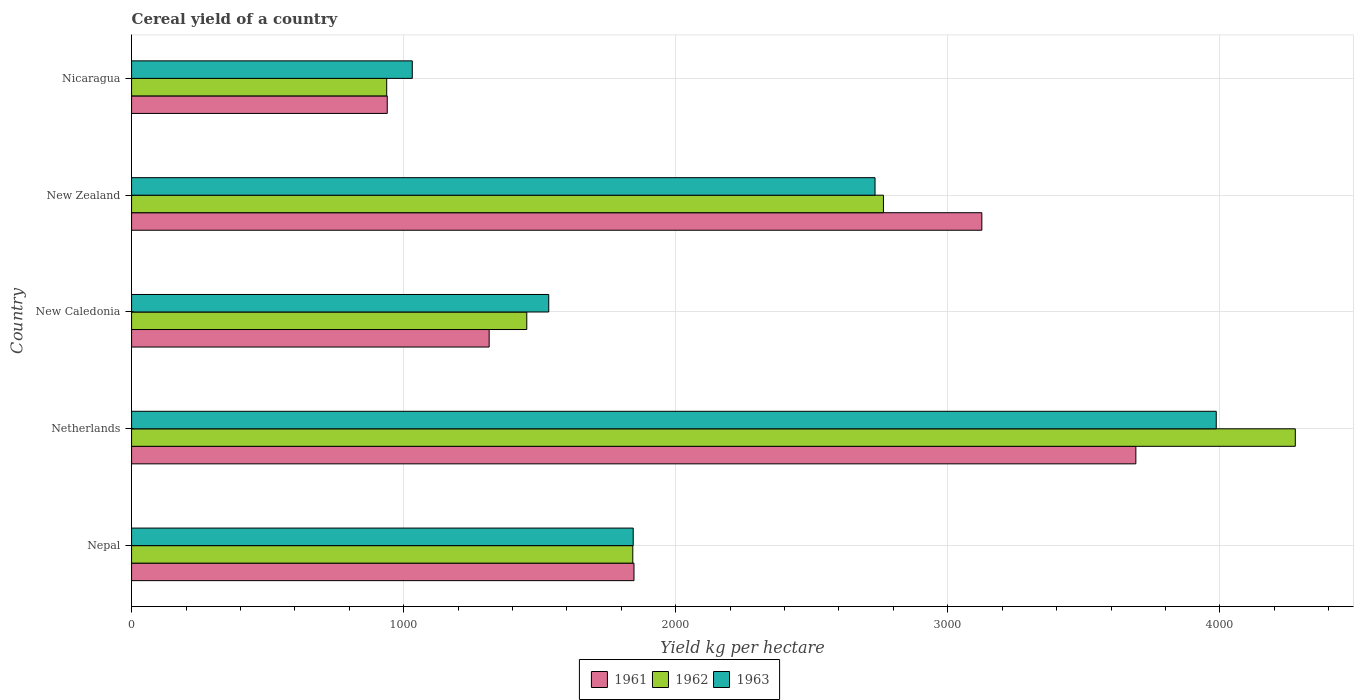How many different coloured bars are there?
Provide a short and direct response. 3. How many groups of bars are there?
Your answer should be very brief. 5. Are the number of bars per tick equal to the number of legend labels?
Keep it short and to the point. Yes. How many bars are there on the 5th tick from the top?
Keep it short and to the point. 3. How many bars are there on the 5th tick from the bottom?
Provide a short and direct response. 3. What is the label of the 4th group of bars from the top?
Your answer should be very brief. Netherlands. In how many cases, is the number of bars for a given country not equal to the number of legend labels?
Keep it short and to the point. 0. What is the total cereal yield in 1962 in Nicaragua?
Your answer should be compact. 937.73. Across all countries, what is the maximum total cereal yield in 1961?
Your answer should be very brief. 3691.39. Across all countries, what is the minimum total cereal yield in 1962?
Keep it short and to the point. 937.73. In which country was the total cereal yield in 1963 minimum?
Provide a succinct answer. Nicaragua. What is the total total cereal yield in 1961 in the graph?
Keep it short and to the point. 1.09e+04. What is the difference between the total cereal yield in 1962 in New Zealand and that in Nicaragua?
Your answer should be compact. 1825.84. What is the difference between the total cereal yield in 1961 in Nicaragua and the total cereal yield in 1962 in Nepal?
Your answer should be compact. -902.57. What is the average total cereal yield in 1961 per country?
Keep it short and to the point. 2183.46. What is the difference between the total cereal yield in 1961 and total cereal yield in 1962 in Nepal?
Provide a succinct answer. 4.36. In how many countries, is the total cereal yield in 1963 greater than 800 kg per hectare?
Make the answer very short. 5. What is the ratio of the total cereal yield in 1963 in New Zealand to that in Nicaragua?
Your answer should be very brief. 2.65. Is the total cereal yield in 1963 in New Zealand less than that in Nicaragua?
Offer a very short reply. No. What is the difference between the highest and the second highest total cereal yield in 1962?
Make the answer very short. 1513.86. What is the difference between the highest and the lowest total cereal yield in 1962?
Make the answer very short. 3339.7. In how many countries, is the total cereal yield in 1961 greater than the average total cereal yield in 1961 taken over all countries?
Provide a short and direct response. 2. Is it the case that in every country, the sum of the total cereal yield in 1963 and total cereal yield in 1961 is greater than the total cereal yield in 1962?
Your response must be concise. Yes. What is the difference between two consecutive major ticks on the X-axis?
Provide a succinct answer. 1000. Are the values on the major ticks of X-axis written in scientific E-notation?
Make the answer very short. No. Does the graph contain any zero values?
Your answer should be very brief. No. Does the graph contain grids?
Your answer should be very brief. Yes. What is the title of the graph?
Make the answer very short. Cereal yield of a country. What is the label or title of the X-axis?
Your response must be concise. Yield kg per hectare. What is the label or title of the Y-axis?
Give a very brief answer. Country. What is the Yield kg per hectare in 1961 in Nepal?
Your response must be concise. 1846.65. What is the Yield kg per hectare in 1962 in Nepal?
Offer a very short reply. 1842.29. What is the Yield kg per hectare of 1963 in Nepal?
Keep it short and to the point. 1843.86. What is the Yield kg per hectare in 1961 in Netherlands?
Your response must be concise. 3691.39. What is the Yield kg per hectare of 1962 in Netherlands?
Offer a terse response. 4277.43. What is the Yield kg per hectare of 1963 in Netherlands?
Make the answer very short. 3986.86. What is the Yield kg per hectare in 1961 in New Caledonia?
Offer a terse response. 1314.29. What is the Yield kg per hectare in 1962 in New Caledonia?
Give a very brief answer. 1452.63. What is the Yield kg per hectare of 1963 in New Caledonia?
Offer a terse response. 1533.33. What is the Yield kg per hectare in 1961 in New Zealand?
Make the answer very short. 3125.27. What is the Yield kg per hectare of 1962 in New Zealand?
Offer a very short reply. 2763.57. What is the Yield kg per hectare in 1963 in New Zealand?
Provide a succinct answer. 2732.64. What is the Yield kg per hectare in 1961 in Nicaragua?
Your answer should be very brief. 939.72. What is the Yield kg per hectare of 1962 in Nicaragua?
Ensure brevity in your answer.  937.73. What is the Yield kg per hectare in 1963 in Nicaragua?
Give a very brief answer. 1031.73. Across all countries, what is the maximum Yield kg per hectare of 1961?
Offer a very short reply. 3691.39. Across all countries, what is the maximum Yield kg per hectare in 1962?
Give a very brief answer. 4277.43. Across all countries, what is the maximum Yield kg per hectare of 1963?
Provide a short and direct response. 3986.86. Across all countries, what is the minimum Yield kg per hectare of 1961?
Ensure brevity in your answer.  939.72. Across all countries, what is the minimum Yield kg per hectare of 1962?
Provide a succinct answer. 937.73. Across all countries, what is the minimum Yield kg per hectare of 1963?
Offer a very short reply. 1031.73. What is the total Yield kg per hectare of 1961 in the graph?
Make the answer very short. 1.09e+04. What is the total Yield kg per hectare of 1962 in the graph?
Offer a terse response. 1.13e+04. What is the total Yield kg per hectare in 1963 in the graph?
Offer a terse response. 1.11e+04. What is the difference between the Yield kg per hectare in 1961 in Nepal and that in Netherlands?
Give a very brief answer. -1844.74. What is the difference between the Yield kg per hectare of 1962 in Nepal and that in Netherlands?
Ensure brevity in your answer.  -2435.14. What is the difference between the Yield kg per hectare in 1963 in Nepal and that in Netherlands?
Make the answer very short. -2143. What is the difference between the Yield kg per hectare of 1961 in Nepal and that in New Caledonia?
Offer a terse response. 532.36. What is the difference between the Yield kg per hectare in 1962 in Nepal and that in New Caledonia?
Offer a terse response. 389.66. What is the difference between the Yield kg per hectare in 1963 in Nepal and that in New Caledonia?
Give a very brief answer. 310.53. What is the difference between the Yield kg per hectare in 1961 in Nepal and that in New Zealand?
Ensure brevity in your answer.  -1278.62. What is the difference between the Yield kg per hectare of 1962 in Nepal and that in New Zealand?
Your answer should be compact. -921.28. What is the difference between the Yield kg per hectare of 1963 in Nepal and that in New Zealand?
Your answer should be very brief. -888.78. What is the difference between the Yield kg per hectare in 1961 in Nepal and that in Nicaragua?
Your response must be concise. 906.93. What is the difference between the Yield kg per hectare in 1962 in Nepal and that in Nicaragua?
Give a very brief answer. 904.56. What is the difference between the Yield kg per hectare in 1963 in Nepal and that in Nicaragua?
Offer a terse response. 812.13. What is the difference between the Yield kg per hectare of 1961 in Netherlands and that in New Caledonia?
Provide a short and direct response. 2377.1. What is the difference between the Yield kg per hectare in 1962 in Netherlands and that in New Caledonia?
Offer a very short reply. 2824.8. What is the difference between the Yield kg per hectare in 1963 in Netherlands and that in New Caledonia?
Offer a terse response. 2453.53. What is the difference between the Yield kg per hectare of 1961 in Netherlands and that in New Zealand?
Offer a terse response. 566.12. What is the difference between the Yield kg per hectare in 1962 in Netherlands and that in New Zealand?
Ensure brevity in your answer.  1513.86. What is the difference between the Yield kg per hectare in 1963 in Netherlands and that in New Zealand?
Your answer should be compact. 1254.22. What is the difference between the Yield kg per hectare in 1961 in Netherlands and that in Nicaragua?
Offer a terse response. 2751.66. What is the difference between the Yield kg per hectare of 1962 in Netherlands and that in Nicaragua?
Your answer should be very brief. 3339.7. What is the difference between the Yield kg per hectare in 1963 in Netherlands and that in Nicaragua?
Your answer should be very brief. 2955.14. What is the difference between the Yield kg per hectare in 1961 in New Caledonia and that in New Zealand?
Offer a terse response. -1810.98. What is the difference between the Yield kg per hectare in 1962 in New Caledonia and that in New Zealand?
Offer a very short reply. -1310.93. What is the difference between the Yield kg per hectare of 1963 in New Caledonia and that in New Zealand?
Offer a terse response. -1199.31. What is the difference between the Yield kg per hectare of 1961 in New Caledonia and that in Nicaragua?
Make the answer very short. 374.56. What is the difference between the Yield kg per hectare of 1962 in New Caledonia and that in Nicaragua?
Provide a succinct answer. 514.91. What is the difference between the Yield kg per hectare in 1963 in New Caledonia and that in Nicaragua?
Offer a terse response. 501.61. What is the difference between the Yield kg per hectare in 1961 in New Zealand and that in Nicaragua?
Make the answer very short. 2185.55. What is the difference between the Yield kg per hectare in 1962 in New Zealand and that in Nicaragua?
Your answer should be compact. 1825.84. What is the difference between the Yield kg per hectare of 1963 in New Zealand and that in Nicaragua?
Ensure brevity in your answer.  1700.92. What is the difference between the Yield kg per hectare of 1961 in Nepal and the Yield kg per hectare of 1962 in Netherlands?
Your response must be concise. -2430.78. What is the difference between the Yield kg per hectare in 1961 in Nepal and the Yield kg per hectare in 1963 in Netherlands?
Provide a succinct answer. -2140.22. What is the difference between the Yield kg per hectare in 1962 in Nepal and the Yield kg per hectare in 1963 in Netherlands?
Provide a short and direct response. -2144.57. What is the difference between the Yield kg per hectare in 1961 in Nepal and the Yield kg per hectare in 1962 in New Caledonia?
Ensure brevity in your answer.  394.01. What is the difference between the Yield kg per hectare in 1961 in Nepal and the Yield kg per hectare in 1963 in New Caledonia?
Make the answer very short. 313.31. What is the difference between the Yield kg per hectare of 1962 in Nepal and the Yield kg per hectare of 1963 in New Caledonia?
Your answer should be very brief. 308.95. What is the difference between the Yield kg per hectare in 1961 in Nepal and the Yield kg per hectare in 1962 in New Zealand?
Keep it short and to the point. -916.92. What is the difference between the Yield kg per hectare in 1961 in Nepal and the Yield kg per hectare in 1963 in New Zealand?
Provide a succinct answer. -886. What is the difference between the Yield kg per hectare of 1962 in Nepal and the Yield kg per hectare of 1963 in New Zealand?
Provide a succinct answer. -890.36. What is the difference between the Yield kg per hectare of 1961 in Nepal and the Yield kg per hectare of 1962 in Nicaragua?
Your answer should be very brief. 908.92. What is the difference between the Yield kg per hectare in 1961 in Nepal and the Yield kg per hectare in 1963 in Nicaragua?
Offer a very short reply. 814.92. What is the difference between the Yield kg per hectare of 1962 in Nepal and the Yield kg per hectare of 1963 in Nicaragua?
Your answer should be very brief. 810.56. What is the difference between the Yield kg per hectare in 1961 in Netherlands and the Yield kg per hectare in 1962 in New Caledonia?
Offer a terse response. 2238.75. What is the difference between the Yield kg per hectare of 1961 in Netherlands and the Yield kg per hectare of 1963 in New Caledonia?
Your answer should be very brief. 2158.05. What is the difference between the Yield kg per hectare of 1962 in Netherlands and the Yield kg per hectare of 1963 in New Caledonia?
Your answer should be very brief. 2744.1. What is the difference between the Yield kg per hectare of 1961 in Netherlands and the Yield kg per hectare of 1962 in New Zealand?
Your answer should be very brief. 927.82. What is the difference between the Yield kg per hectare in 1961 in Netherlands and the Yield kg per hectare in 1963 in New Zealand?
Provide a succinct answer. 958.74. What is the difference between the Yield kg per hectare of 1962 in Netherlands and the Yield kg per hectare of 1963 in New Zealand?
Make the answer very short. 1544.79. What is the difference between the Yield kg per hectare of 1961 in Netherlands and the Yield kg per hectare of 1962 in Nicaragua?
Keep it short and to the point. 2753.66. What is the difference between the Yield kg per hectare of 1961 in Netherlands and the Yield kg per hectare of 1963 in Nicaragua?
Ensure brevity in your answer.  2659.66. What is the difference between the Yield kg per hectare of 1962 in Netherlands and the Yield kg per hectare of 1963 in Nicaragua?
Give a very brief answer. 3245.7. What is the difference between the Yield kg per hectare of 1961 in New Caledonia and the Yield kg per hectare of 1962 in New Zealand?
Your answer should be compact. -1449.28. What is the difference between the Yield kg per hectare of 1961 in New Caledonia and the Yield kg per hectare of 1963 in New Zealand?
Your answer should be very brief. -1418.36. What is the difference between the Yield kg per hectare of 1962 in New Caledonia and the Yield kg per hectare of 1963 in New Zealand?
Keep it short and to the point. -1280.01. What is the difference between the Yield kg per hectare of 1961 in New Caledonia and the Yield kg per hectare of 1962 in Nicaragua?
Keep it short and to the point. 376.56. What is the difference between the Yield kg per hectare in 1961 in New Caledonia and the Yield kg per hectare in 1963 in Nicaragua?
Your answer should be very brief. 282.56. What is the difference between the Yield kg per hectare in 1962 in New Caledonia and the Yield kg per hectare in 1963 in Nicaragua?
Your answer should be compact. 420.91. What is the difference between the Yield kg per hectare of 1961 in New Zealand and the Yield kg per hectare of 1962 in Nicaragua?
Your answer should be very brief. 2187.54. What is the difference between the Yield kg per hectare of 1961 in New Zealand and the Yield kg per hectare of 1963 in Nicaragua?
Your response must be concise. 2093.54. What is the difference between the Yield kg per hectare in 1962 in New Zealand and the Yield kg per hectare in 1963 in Nicaragua?
Provide a short and direct response. 1731.84. What is the average Yield kg per hectare of 1961 per country?
Your answer should be compact. 2183.46. What is the average Yield kg per hectare in 1962 per country?
Ensure brevity in your answer.  2254.73. What is the average Yield kg per hectare in 1963 per country?
Provide a succinct answer. 2225.68. What is the difference between the Yield kg per hectare of 1961 and Yield kg per hectare of 1962 in Nepal?
Your answer should be compact. 4.36. What is the difference between the Yield kg per hectare of 1961 and Yield kg per hectare of 1963 in Nepal?
Offer a terse response. 2.79. What is the difference between the Yield kg per hectare in 1962 and Yield kg per hectare in 1963 in Nepal?
Make the answer very short. -1.57. What is the difference between the Yield kg per hectare of 1961 and Yield kg per hectare of 1962 in Netherlands?
Keep it short and to the point. -586.04. What is the difference between the Yield kg per hectare of 1961 and Yield kg per hectare of 1963 in Netherlands?
Keep it short and to the point. -295.48. What is the difference between the Yield kg per hectare in 1962 and Yield kg per hectare in 1963 in Netherlands?
Make the answer very short. 290.57. What is the difference between the Yield kg per hectare of 1961 and Yield kg per hectare of 1962 in New Caledonia?
Your answer should be compact. -138.35. What is the difference between the Yield kg per hectare in 1961 and Yield kg per hectare in 1963 in New Caledonia?
Your answer should be compact. -219.05. What is the difference between the Yield kg per hectare of 1962 and Yield kg per hectare of 1963 in New Caledonia?
Provide a short and direct response. -80.7. What is the difference between the Yield kg per hectare in 1961 and Yield kg per hectare in 1962 in New Zealand?
Your answer should be compact. 361.7. What is the difference between the Yield kg per hectare in 1961 and Yield kg per hectare in 1963 in New Zealand?
Keep it short and to the point. 392.62. What is the difference between the Yield kg per hectare of 1962 and Yield kg per hectare of 1963 in New Zealand?
Provide a succinct answer. 30.92. What is the difference between the Yield kg per hectare of 1961 and Yield kg per hectare of 1962 in Nicaragua?
Offer a very short reply. 2. What is the difference between the Yield kg per hectare in 1961 and Yield kg per hectare in 1963 in Nicaragua?
Your answer should be compact. -92. What is the difference between the Yield kg per hectare of 1962 and Yield kg per hectare of 1963 in Nicaragua?
Offer a very short reply. -94. What is the ratio of the Yield kg per hectare in 1961 in Nepal to that in Netherlands?
Offer a terse response. 0.5. What is the ratio of the Yield kg per hectare of 1962 in Nepal to that in Netherlands?
Keep it short and to the point. 0.43. What is the ratio of the Yield kg per hectare in 1963 in Nepal to that in Netherlands?
Offer a terse response. 0.46. What is the ratio of the Yield kg per hectare in 1961 in Nepal to that in New Caledonia?
Offer a very short reply. 1.41. What is the ratio of the Yield kg per hectare in 1962 in Nepal to that in New Caledonia?
Give a very brief answer. 1.27. What is the ratio of the Yield kg per hectare of 1963 in Nepal to that in New Caledonia?
Provide a succinct answer. 1.2. What is the ratio of the Yield kg per hectare of 1961 in Nepal to that in New Zealand?
Offer a very short reply. 0.59. What is the ratio of the Yield kg per hectare of 1962 in Nepal to that in New Zealand?
Your response must be concise. 0.67. What is the ratio of the Yield kg per hectare in 1963 in Nepal to that in New Zealand?
Your answer should be compact. 0.67. What is the ratio of the Yield kg per hectare of 1961 in Nepal to that in Nicaragua?
Make the answer very short. 1.97. What is the ratio of the Yield kg per hectare of 1962 in Nepal to that in Nicaragua?
Make the answer very short. 1.96. What is the ratio of the Yield kg per hectare in 1963 in Nepal to that in Nicaragua?
Give a very brief answer. 1.79. What is the ratio of the Yield kg per hectare in 1961 in Netherlands to that in New Caledonia?
Your response must be concise. 2.81. What is the ratio of the Yield kg per hectare in 1962 in Netherlands to that in New Caledonia?
Make the answer very short. 2.94. What is the ratio of the Yield kg per hectare in 1963 in Netherlands to that in New Caledonia?
Provide a short and direct response. 2.6. What is the ratio of the Yield kg per hectare of 1961 in Netherlands to that in New Zealand?
Provide a short and direct response. 1.18. What is the ratio of the Yield kg per hectare in 1962 in Netherlands to that in New Zealand?
Your response must be concise. 1.55. What is the ratio of the Yield kg per hectare of 1963 in Netherlands to that in New Zealand?
Ensure brevity in your answer.  1.46. What is the ratio of the Yield kg per hectare of 1961 in Netherlands to that in Nicaragua?
Provide a succinct answer. 3.93. What is the ratio of the Yield kg per hectare of 1962 in Netherlands to that in Nicaragua?
Make the answer very short. 4.56. What is the ratio of the Yield kg per hectare in 1963 in Netherlands to that in Nicaragua?
Provide a succinct answer. 3.86. What is the ratio of the Yield kg per hectare in 1961 in New Caledonia to that in New Zealand?
Provide a succinct answer. 0.42. What is the ratio of the Yield kg per hectare in 1962 in New Caledonia to that in New Zealand?
Provide a short and direct response. 0.53. What is the ratio of the Yield kg per hectare in 1963 in New Caledonia to that in New Zealand?
Provide a succinct answer. 0.56. What is the ratio of the Yield kg per hectare in 1961 in New Caledonia to that in Nicaragua?
Keep it short and to the point. 1.4. What is the ratio of the Yield kg per hectare of 1962 in New Caledonia to that in Nicaragua?
Your answer should be very brief. 1.55. What is the ratio of the Yield kg per hectare of 1963 in New Caledonia to that in Nicaragua?
Provide a succinct answer. 1.49. What is the ratio of the Yield kg per hectare in 1961 in New Zealand to that in Nicaragua?
Offer a terse response. 3.33. What is the ratio of the Yield kg per hectare of 1962 in New Zealand to that in Nicaragua?
Your answer should be very brief. 2.95. What is the ratio of the Yield kg per hectare of 1963 in New Zealand to that in Nicaragua?
Offer a very short reply. 2.65. What is the difference between the highest and the second highest Yield kg per hectare of 1961?
Give a very brief answer. 566.12. What is the difference between the highest and the second highest Yield kg per hectare in 1962?
Your response must be concise. 1513.86. What is the difference between the highest and the second highest Yield kg per hectare in 1963?
Offer a very short reply. 1254.22. What is the difference between the highest and the lowest Yield kg per hectare in 1961?
Your answer should be compact. 2751.66. What is the difference between the highest and the lowest Yield kg per hectare of 1962?
Ensure brevity in your answer.  3339.7. What is the difference between the highest and the lowest Yield kg per hectare in 1963?
Make the answer very short. 2955.14. 